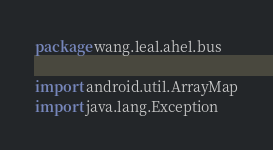Convert code to text. <code><loc_0><loc_0><loc_500><loc_500><_Kotlin_>package wang.leal.ahel.bus

import android.util.ArrayMap
import java.lang.Exception
</code> 